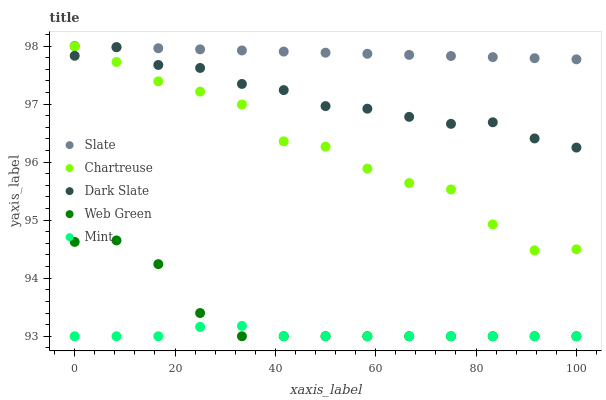Does Mint have the minimum area under the curve?
Answer yes or no. Yes. Does Slate have the maximum area under the curve?
Answer yes or no. Yes. Does Slate have the minimum area under the curve?
Answer yes or no. No. Does Mint have the maximum area under the curve?
Answer yes or no. No. Is Slate the smoothest?
Answer yes or no. Yes. Is Chartreuse the roughest?
Answer yes or no. Yes. Is Mint the smoothest?
Answer yes or no. No. Is Mint the roughest?
Answer yes or no. No. Does Mint have the lowest value?
Answer yes or no. Yes. Does Slate have the lowest value?
Answer yes or no. No. Does Slate have the highest value?
Answer yes or no. Yes. Does Mint have the highest value?
Answer yes or no. No. Is Dark Slate less than Slate?
Answer yes or no. Yes. Is Slate greater than Dark Slate?
Answer yes or no. Yes. Does Chartreuse intersect Dark Slate?
Answer yes or no. Yes. Is Chartreuse less than Dark Slate?
Answer yes or no. No. Is Chartreuse greater than Dark Slate?
Answer yes or no. No. Does Dark Slate intersect Slate?
Answer yes or no. No. 